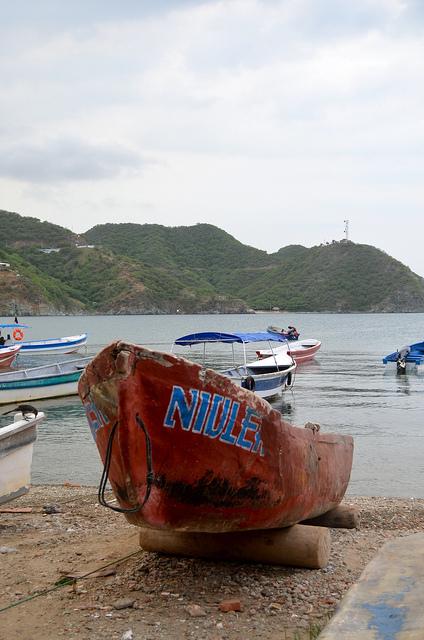Is the red boat new?
Be succinct. No. What does the boat say?
Write a very short answer. Nile. Could you water ski with this boat?
Short answer required. No. 